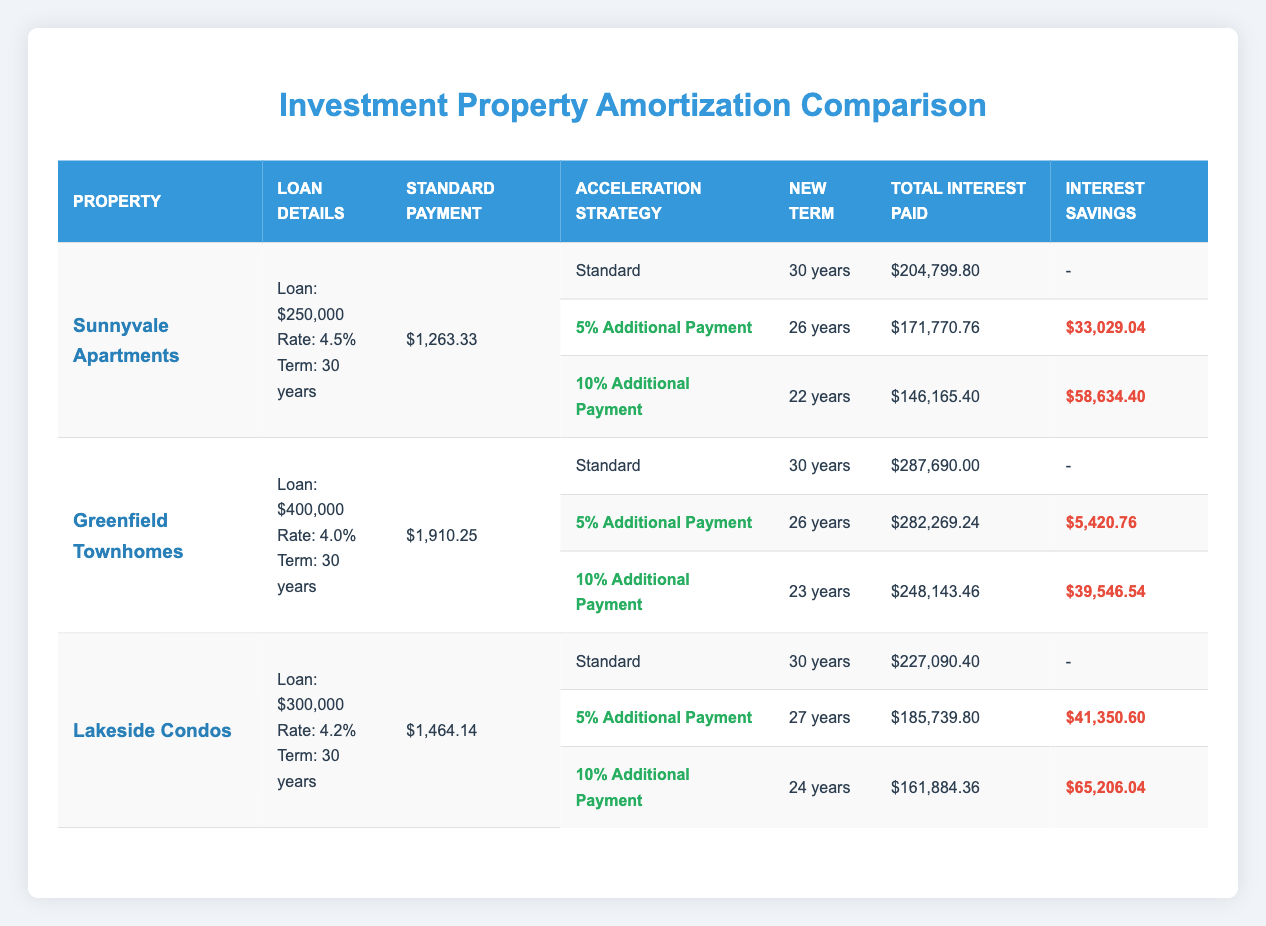What is the loan amount for Sunnyvale Apartments? The table states that the loan amount for Sunnyvale Apartments is $250,000, as indicated in the Loan Details column for that property.
Answer: $250,000 How much would the total interest paid be if a 10% additional payment strategy is used for Lakeside Condos? The table shows that the total interest paid when using the 10% additional payment for Lakeside Condos is $161,884.36, found in the corresponding row under Total Interest Paid.
Answer: $161,884.36 What is the difference in total interest paid between the 10% additional payment strategy and the standard payment for Greenfield Townhomes? The total interest paid for Greenfield Townhomes with the standard payment is $287,690.00, and with the 10% additional payment, it is $248,143.46. The difference is calculated as $287,690.00 - $248,143.46 = $39,546.54.
Answer: $39,546.54 Is it true that the new term for a 5% additional payment strategy at Lakeside Condos is 27 years? Looking at the table, it confirms that the new term for a 5% additional payment strategy under Lakeside Condos is indeed 27 years, as stated in the New Term column.
Answer: Yes Which property has the highest total interest savings with the 10% additional payment strategy? To find which property offers the highest total interest savings with the 10% additional payment strategy, we compare the savings values: Sunnyvale Apartments has $58,634.40, Greenfield Townhomes has $39,546.54, and Lakeside Condos has $65,206.04. Lakeside Condos has the highest savings of $65,206.04.
Answer: Lakeside Condos 